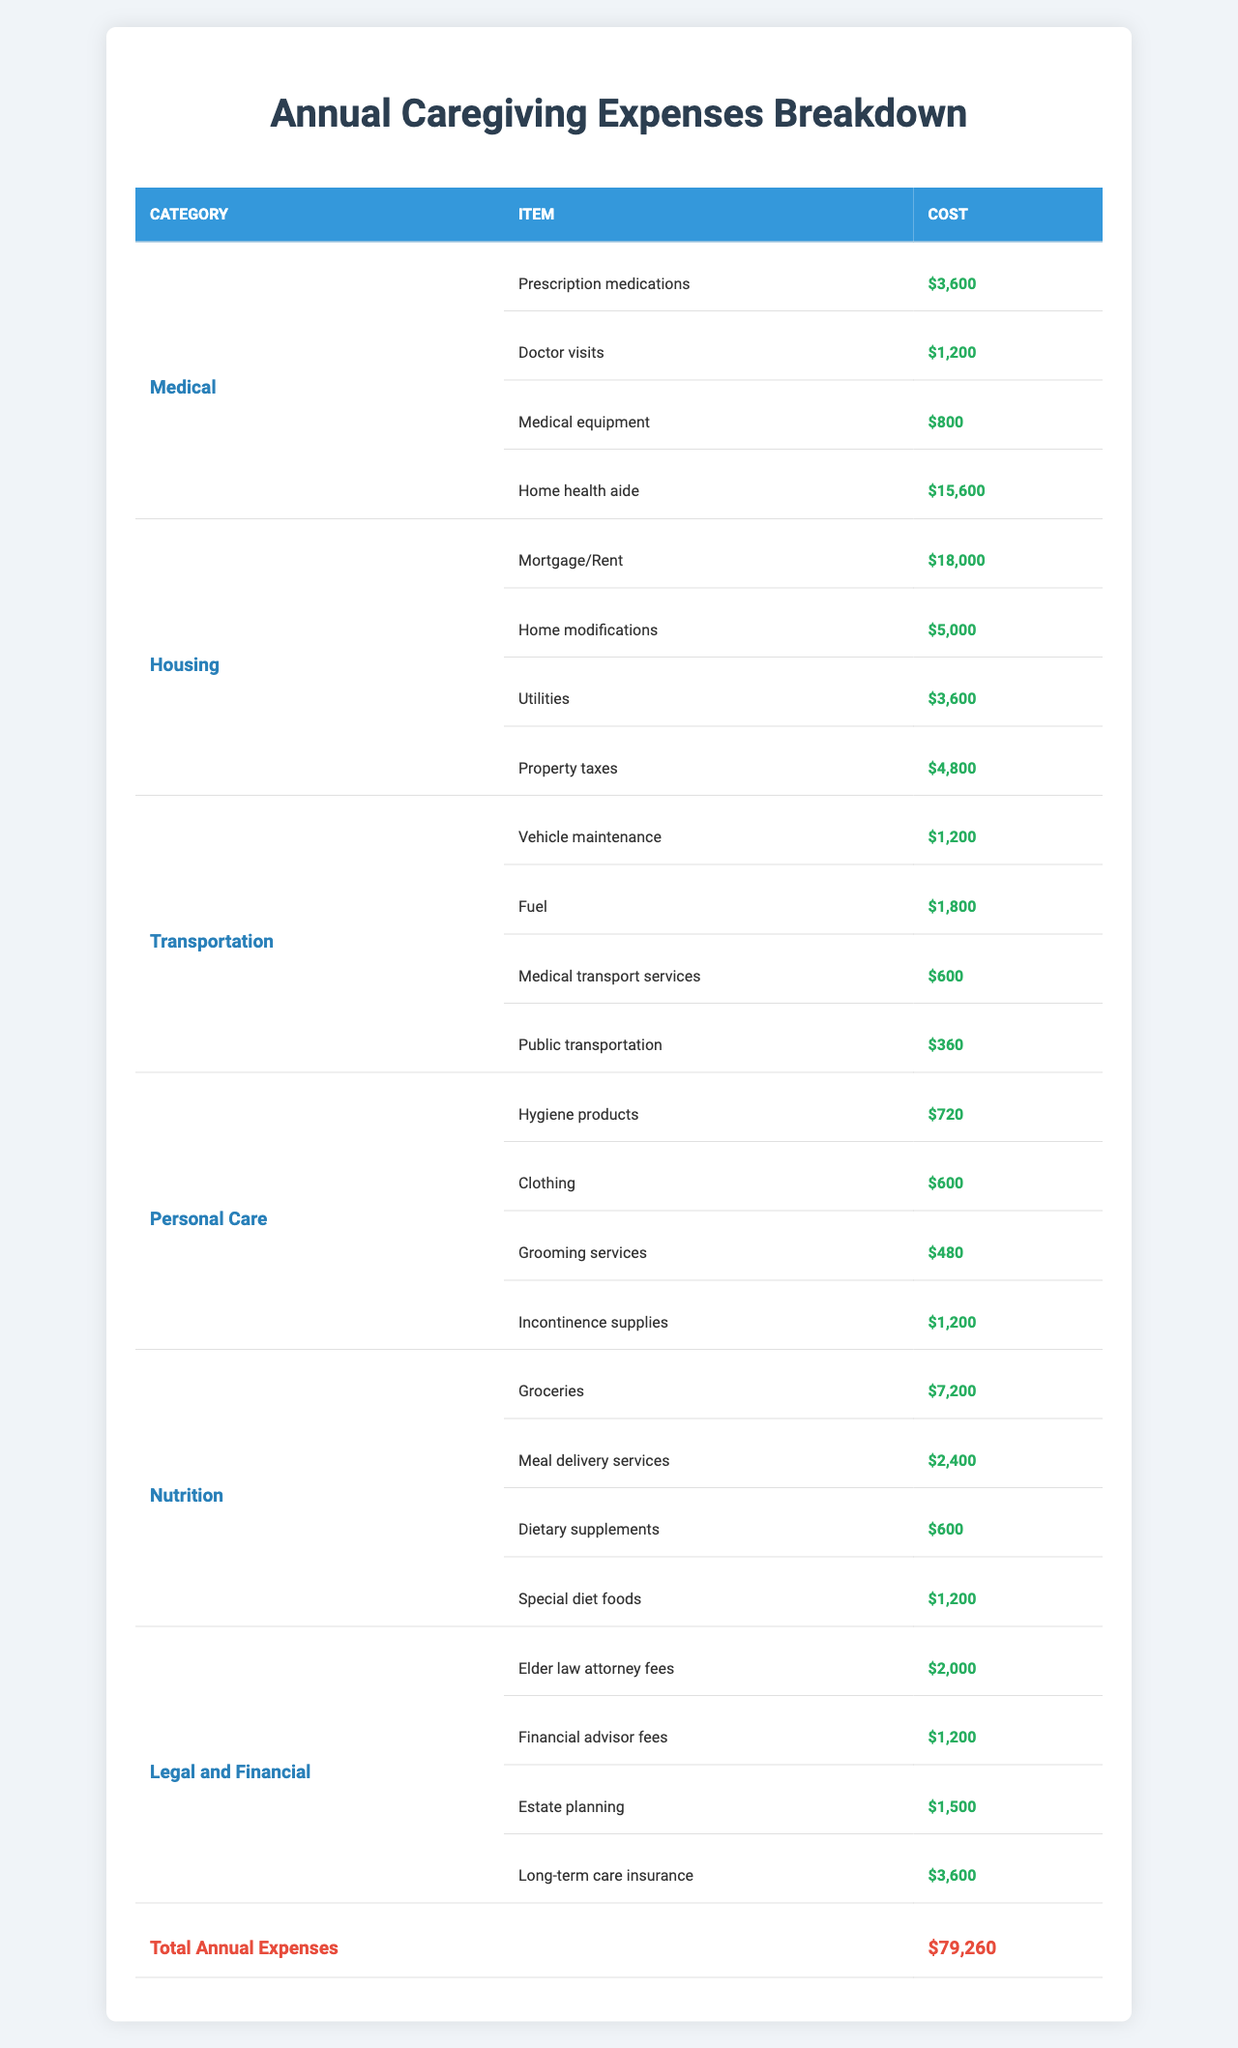What is the total cost of Medical expenses? The Medical category has four items: Prescription medications ($3600), Doctor visits ($1200), Medical equipment ($800), and Home health aide ($15600). Summing these up gives $3600 + $1200 + $800 + $15600 = $21500.
Answer: $21500 Which category has the highest total expenses? To find the highest total expenses, we need to calculate the total for each category. The totals are: Medical - $21500, Housing - $30000, Transportation - $3960, Personal Care - $3000, Nutrition - $12000, and Legal and Financial - $9300. Housing has the highest total at $30000.
Answer: Housing What is the combined cost of Transportation and Personal Care expenses? The total for Transportation is $3960, and for Personal Care, it is $3000. Adding these amounts gives $3960 + $3000 = $6960.
Answer: $6960 Is the cost of Home modifications more than the cost of Property taxes? The cost of Home modifications is $5000, and the cost of Property taxes is $4800. Since $5000 is greater than $4800, the statement is true.
Answer: Yes What is the average cost of items in the Nutrition category? The Nutrition category has four items: Groceries ($7200), Meal delivery services ($2400), Dietary supplements ($600), and Special diet foods ($1200). The total cost is $7200 + $2400 + $600 + $1200 = $10800. There are four items, so the average is $10800 / 4 = $2700.
Answer: $2700 How much more is spent on Mortgage/Rent compared to Vehicle maintenance? Mortgage/Rent costs $18000, while Vehicle maintenance costs $1200. The difference is $18000 - $1200 = $16800.
Answer: $16800 Calculate the total expenses for the Legal and Financial category compared to the Personal Care category. The Legal and Financial expenses total $9300 (Elder law attorney fees: $2000, Financial advisor fees: $1200, Estate planning: $1500, Long-term care insurance: $3600). The Personal Care expenses total $3000 (Hygiene products: $720, Clothing: $600, Grooming services: $480, Incontinence supplies: $1200). The difference is $9300 - $3000 = $6300, showing that Legal and Financial expenses are higher.
Answer: $6300 Which item has the lowest cost in the Personal Care category? The items in the Personal Care category are: Hygiene products ($720), Clothing ($600), Grooming services ($480), and Incontinence supplies ($1200). The lowest cost is for Grooming services, which is $480.
Answer: $480 What is the total cost of groceries and dietary supplements combined? Groceries cost $7200 and Dietary supplements cost $600. Adding these gives $7200 + $600 = $7800.
Answer: $7800 Compare the cost of Home health aide and Meal delivery services. Which one is more expensive? Home health aide costs $15600 and Meal delivery services costs $2400. Since $15600 is greater than $2400, Home health aide is more expensive.
Answer: Home health aide 